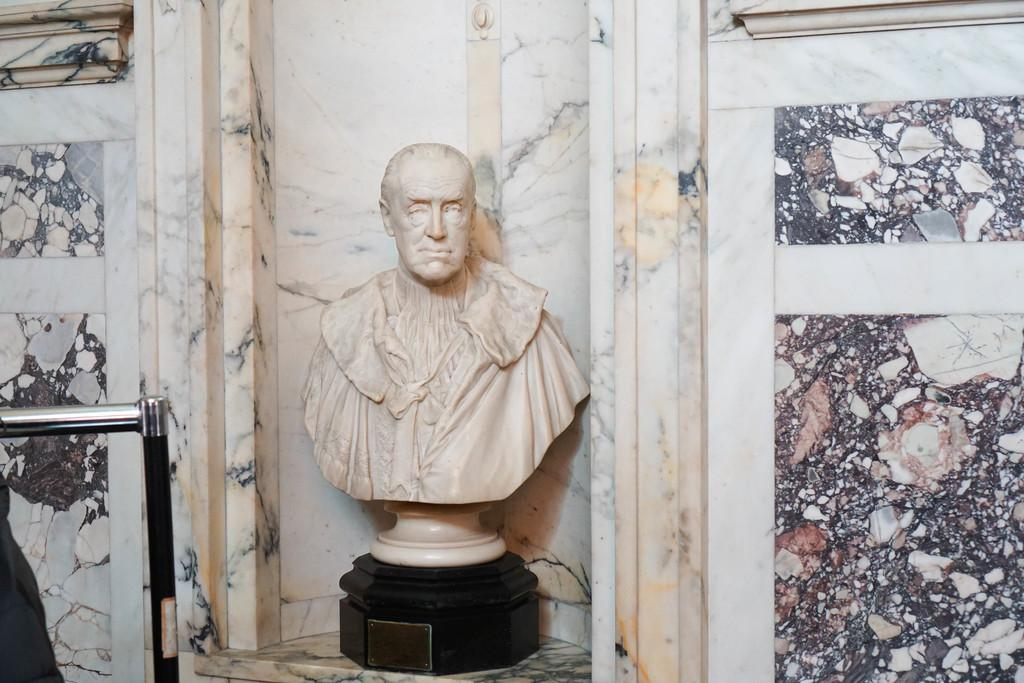What is the main subject of the image? The main subject of the image is a statue of a human. What material is the statue made of? The statue is made up of marble. What can be seen on the left side of the image? There is a steel bar on the left side of the image. What colors are present in the background of the image? White and black color marbles are present in the background of the image. What type of beast is depicted in the image? There is no beast present in the image; it features a statue of a human made of marble. Does the sister of the statue appear in the image? There is no mention of a sister or any other human figure in the image, only the statue of a human. 